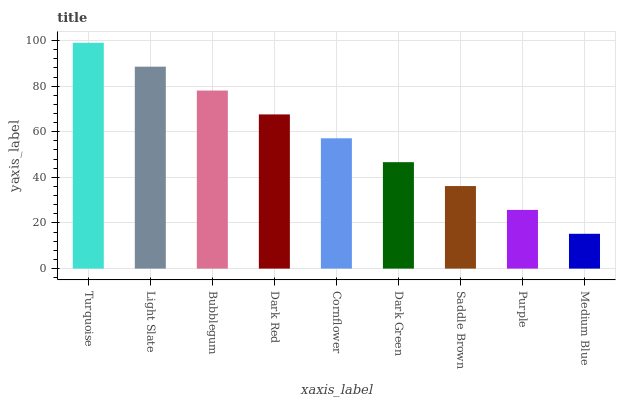Is Light Slate the minimum?
Answer yes or no. No. Is Light Slate the maximum?
Answer yes or no. No. Is Turquoise greater than Light Slate?
Answer yes or no. Yes. Is Light Slate less than Turquoise?
Answer yes or no. Yes. Is Light Slate greater than Turquoise?
Answer yes or no. No. Is Turquoise less than Light Slate?
Answer yes or no. No. Is Cornflower the high median?
Answer yes or no. Yes. Is Cornflower the low median?
Answer yes or no. Yes. Is Purple the high median?
Answer yes or no. No. Is Dark Green the low median?
Answer yes or no. No. 